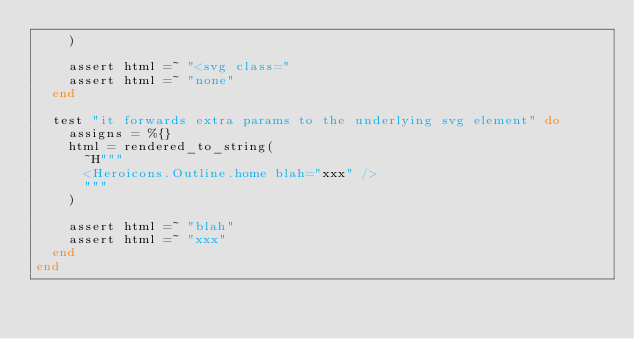<code> <loc_0><loc_0><loc_500><loc_500><_Elixir_>    )

    assert html =~ "<svg class="
    assert html =~ "none"
  end

  test "it forwards extra params to the underlying svg element" do
    assigns = %{}
    html = rendered_to_string(
      ~H"""
      <Heroicons.Outline.home blah="xxx" />
      """
    )

    assert html =~ "blah"
    assert html =~ "xxx"
  end
end
</code> 